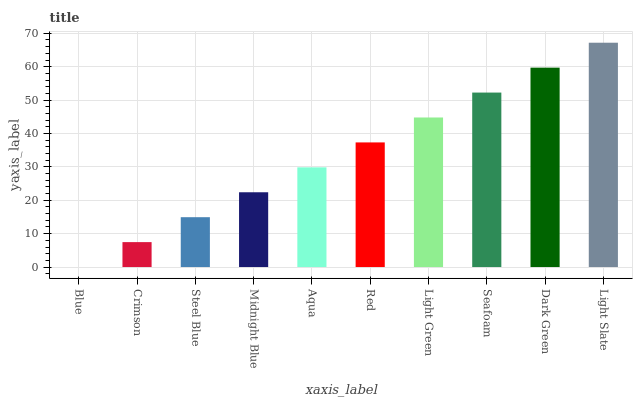Is Crimson the minimum?
Answer yes or no. No. Is Crimson the maximum?
Answer yes or no. No. Is Crimson greater than Blue?
Answer yes or no. Yes. Is Blue less than Crimson?
Answer yes or no. Yes. Is Blue greater than Crimson?
Answer yes or no. No. Is Crimson less than Blue?
Answer yes or no. No. Is Red the high median?
Answer yes or no. Yes. Is Aqua the low median?
Answer yes or no. Yes. Is Steel Blue the high median?
Answer yes or no. No. Is Light Slate the low median?
Answer yes or no. No. 